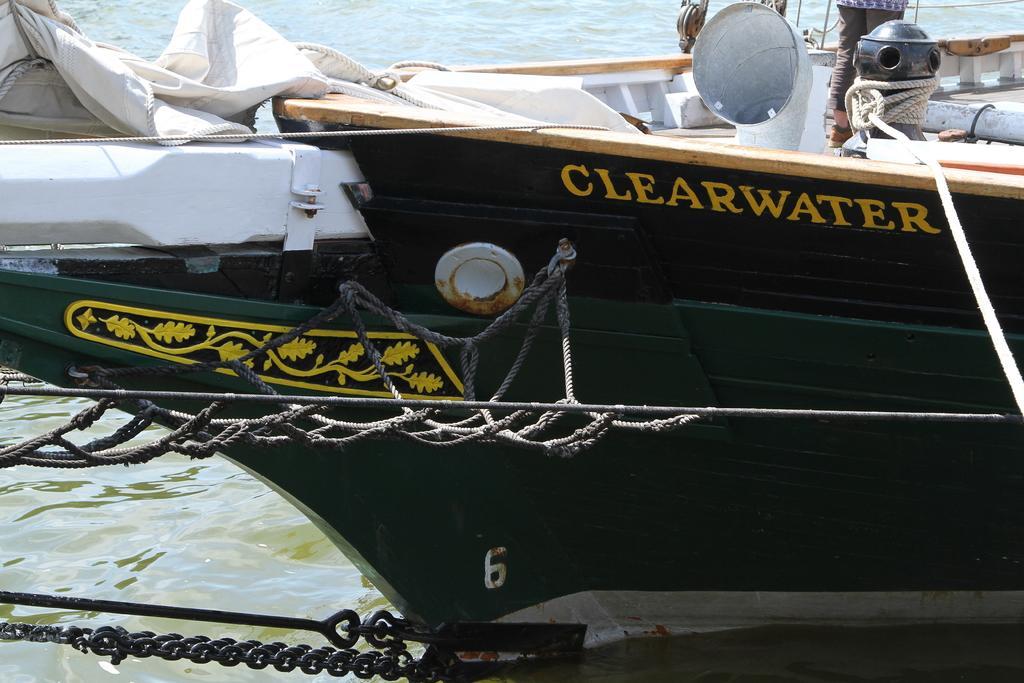Can you describe this image briefly? In the center of the image there is a green color boat. At the bottom of the image there is water. To the left side of the image there is chain. 